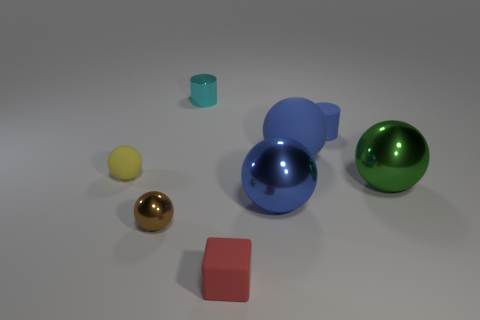What is the shape of the large object behind the tiny matte thing left of the metallic cylinder?
Offer a very short reply. Sphere. Do the rubber thing in front of the yellow matte thing and the cyan cylinder have the same size?
Provide a succinct answer. Yes. How many other objects are the same shape as the tiny yellow matte object?
Offer a very short reply. 4. Is the color of the matte sphere that is behind the yellow rubber object the same as the small rubber block?
Offer a very short reply. No. Are there any tiny rubber things that have the same color as the large matte sphere?
Your response must be concise. Yes. What number of large blue metal balls are behind the tiny blue cylinder?
Ensure brevity in your answer.  0. What number of other objects are the same size as the rubber cylinder?
Offer a terse response. 4. Is the sphere that is in front of the large blue shiny thing made of the same material as the blue ball that is to the right of the blue metallic sphere?
Provide a short and direct response. No. What is the color of the matte cylinder that is the same size as the red object?
Keep it short and to the point. Blue. Is there anything else that is the same color as the tiny rubber cylinder?
Provide a succinct answer. Yes. 